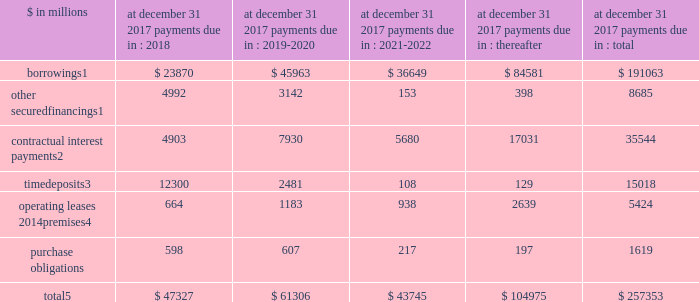Management 2019s discussion and analysis expected replacement of london interbank offered rate central banks around the world , including the federal reserve , have commissioned working groups of market participants and others with the goal of finding suitable replacements for libor based on observable market transac- tions .
It is expected that a transition away from the wide- spread use of libor to alternative rates will occur over the course of the next few years .
Effects of inflation and changes in interest and foreign exchange rates to the extent that an increased inflation outlook results in rising interest rates or has negative impacts on the valuation of financial instruments that exceed the impact on the value of our liabilities , it may adversely affect our financial position and profitability .
Rising inflation may also result in increases in our non-interest expenses that may not be readily recover- able in higher prices of services offered .
Other changes in the interest rate environment and related volatility , as well as expectations about the level of future interest rates , could also impact our results of operations .
A significant portion of our business is conducted in curren- cies other than the u.s .
Dollar , and changes in foreign exchange rates relative to the u.s .
Dollar , therefore , can affect the value of non-u.s .
Dollar net assets , revenues and expenses .
Potential exposures as a result of these fluctuations in currencies are closely monitored , and , where cost-justified , strategies are adopted that are designed to reduce the impact of these fluctuations on our financial performance .
These strategies may include the financing of non-u.s .
Dollar assets with direct or swap-based borrowings in the same currency and the use of currency forward contracts or the spot market in various hedging transactions related to net assets , revenues , expenses or cash flows .
For information about cumulative foreign currency translation adjustments , see note 15 to the financial statements .
Off-balance sheet arrangements and contractual obligations off-balance sheet arrangements we enter into various off-balance sheet arrangements , including through unconsolidated spes and lending-related financial instruments ( e.g. , guarantees and commitments ) , primarily in connection with the institutional securities and investment management business segments .
We utilize spes primarily in connection with securitization activities .
For information on our securitization activities , see note 13 to the financial statements .
For information on our commitments , obligations under certain guarantee arrangements and indemnities , see note 12 to the financial statements .
For further information on our lending commitments , see 201cquantitative and qualitative disclosures about market risk 2014risk management 2014credit risk 2014lending activities . 201d contractual obligations in the normal course of business , we enter into various contractual obligations that may require future cash payments .
Contractual obligations include certain borrow- ings , other secured financings , contractual interest payments , contractual payments on time deposits , operating leases and purchase obligations .
Contractual obligations at december 31 , 2017 payments due in : $ in millions 2018 2019-2020 2021-2022 thereafter total borrowings1 $ 23870 $ 45963 $ 36649 $ 84581 $ 191063 other secured financings1 4992 3142 153 398 8685 contractual interest payments2 4903 7930 5680 17031 35544 time deposits3 12300 2481 108 129 15018 operating leases 2014premises4 664 1183 938 2639 5424 purchase obligations 598 607 217 197 1619 total5 $ 47327 $ 61306 $ 43745 $ 104975 $ 257353 1 .
For further information on borrowings and other secured financings , see note 11 to the financial statements .
Amounts presented for borrowings and other secured financings are financings with original maturities greater than one year .
Amounts represent estimated future contractual interest payments related to unse- cured borrowings with original maturities greater than one year based on applicable interest rates at december 31 , 2017 .
Amounts represent contractual principal and interest payments related to time deposits primarily held at our u.s .
Bank subsidiaries .
For further information on operating leases covering premises and equipment , see note 12 to the financial statements .
Amounts exclude unrecognized tax benefits , as the timing and amount of future cash payments are not determinable at this time ( see note 20 to the financial state- ments for further information ) .
Purchase obligations for goods and services include payments for , among other things , consulting , outsourcing , computer and telecommunications maintenance agreements , and certain transmission , transportation and storage contracts related to the commodities business .
Purchase obligations at december 31 , 2017 reflect the minimum contractual obliga- tion under legally enforceable contracts with contract terms that are both fixed and determinable .
These amounts exclude obligations for goods and services that already have been incurred and are reflected in the balance sheets .
December 2017 form 10-k 70 .
Management 2019s discussion and analysis expected replacement of london interbank offered rate central banks around the world , including the federal reserve , have commissioned working groups of market participants and others with the goal of finding suitable replacements for libor based on observable market transac- tions .
It is expected that a transition away from the wide- spread use of libor to alternative rates will occur over the course of the next few years .
Effects of inflation and changes in interest and foreign exchange rates to the extent that an increased inflation outlook results in rising interest rates or has negative impacts on the valuation of financial instruments that exceed the impact on the value of our liabilities , it may adversely affect our financial position and profitability .
Rising inflation may also result in increases in our non-interest expenses that may not be readily recover- able in higher prices of services offered .
Other changes in the interest rate environment and related volatility , as well as expectations about the level of future interest rates , could also impact our results of operations .
A significant portion of our business is conducted in curren- cies other than the u.s .
Dollar , and changes in foreign exchange rates relative to the u.s .
Dollar , therefore , can affect the value of non-u.s .
Dollar net assets , revenues and expenses .
Potential exposures as a result of these fluctuations in currencies are closely monitored , and , where cost-justified , strategies are adopted that are designed to reduce the impact of these fluctuations on our financial performance .
These strategies may include the financing of non-u.s .
Dollar assets with direct or swap-based borrowings in the same currency and the use of currency forward contracts or the spot market in various hedging transactions related to net assets , revenues , expenses or cash flows .
For information about cumulative foreign currency translation adjustments , see note 15 to the financial statements .
Off-balance sheet arrangements and contractual obligations off-balance sheet arrangements we enter into various off-balance sheet arrangements , including through unconsolidated spes and lending-related financial instruments ( e.g. , guarantees and commitments ) , primarily in connection with the institutional securities and investment management business segments .
We utilize spes primarily in connection with securitization activities .
For information on our securitization activities , see note 13 to the financial statements .
For information on our commitments , obligations under certain guarantee arrangements and indemnities , see note 12 to the financial statements .
For further information on our lending commitments , see 201cquantitative and qualitative disclosures about market risk 2014risk management 2014credit risk 2014lending activities . 201d contractual obligations in the normal course of business , we enter into various contractual obligations that may require future cash payments .
Contractual obligations include certain borrow- ings , other secured financings , contractual interest payments , contractual payments on time deposits , operating leases and purchase obligations .
Contractual obligations at december 31 , 2017 payments due in : $ in millions 2018 2019-2020 2021-2022 thereafter total borrowings1 $ 23870 $ 45963 $ 36649 $ 84581 $ 191063 other secured financings1 4992 3142 153 398 8685 contractual interest payments2 4903 7930 5680 17031 35544 time deposits3 12300 2481 108 129 15018 operating leases 2014premises4 664 1183 938 2639 5424 purchase obligations 598 607 217 197 1619 total5 $ 47327 $ 61306 $ 43745 $ 104975 $ 257353 1 .
For further information on borrowings and other secured financings , see note 11 to the financial statements .
Amounts presented for borrowings and other secured financings are financings with original maturities greater than one year .
Amounts represent estimated future contractual interest payments related to unse- cured borrowings with original maturities greater than one year based on applicable interest rates at december 31 , 2017 .
Amounts represent contractual principal and interest payments related to time deposits primarily held at our u.s .
Bank subsidiaries .
For further information on operating leases covering premises and equipment , see note 12 to the financial statements .
Amounts exclude unrecognized tax benefits , as the timing and amount of future cash payments are not determinable at this time ( see note 20 to the financial state- ments for further information ) .
Purchase obligations for goods and services include payments for , among other things , consulting , outsourcing , computer and telecommunications maintenance agreements , and certain transmission , transportation and storage contracts related to the commodities business .
Purchase obligations at december 31 , 2017 reflect the minimum contractual obliga- tion under legally enforceable contracts with contract terms that are both fixed and determinable .
These amounts exclude obligations for goods and services that already have been incurred and are reflected in the balance sheets .
December 2017 form 10-k 70 .
What percentage of total payments due in 2018 are time deposits? 
Computations: (12300 / 47327)
Answer: 0.25989. 